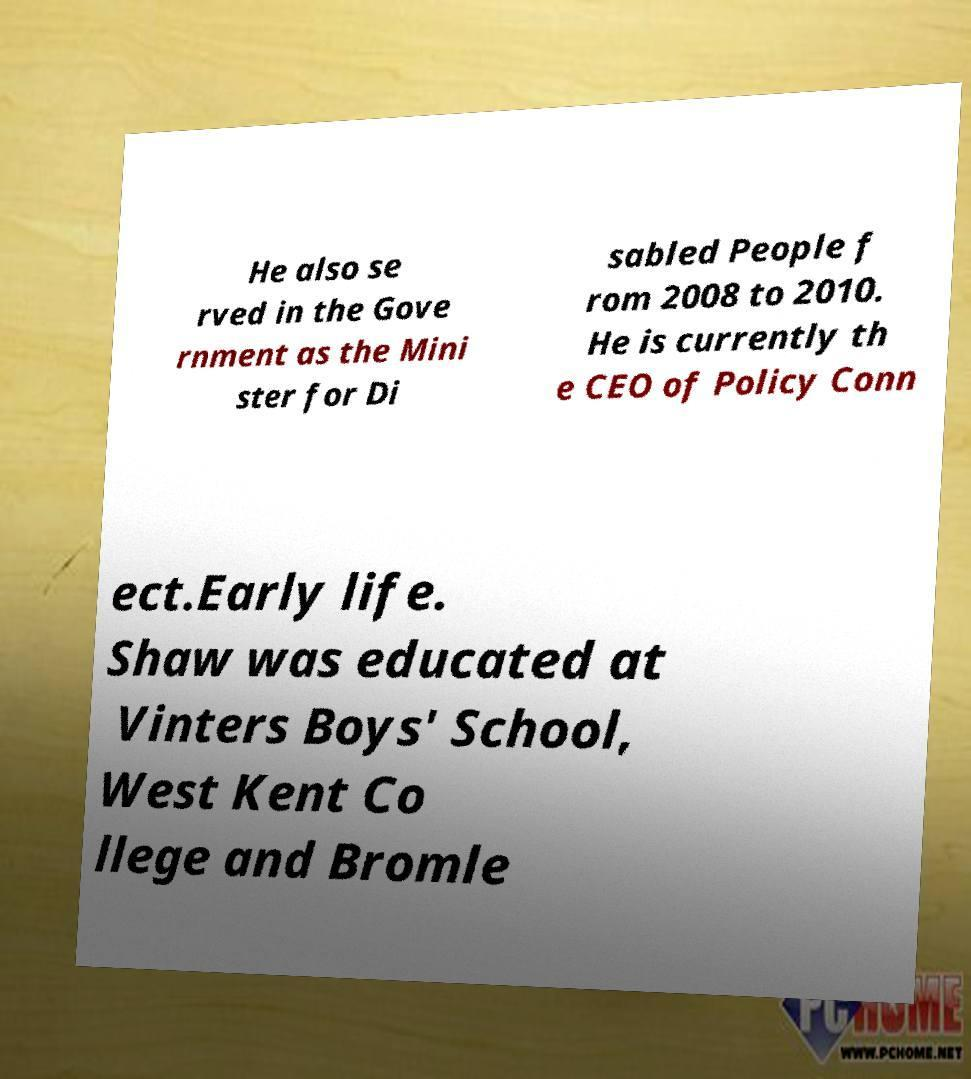Can you read and provide the text displayed in the image?This photo seems to have some interesting text. Can you extract and type it out for me? He also se rved in the Gove rnment as the Mini ster for Di sabled People f rom 2008 to 2010. He is currently th e CEO of Policy Conn ect.Early life. Shaw was educated at Vinters Boys' School, West Kent Co llege and Bromle 